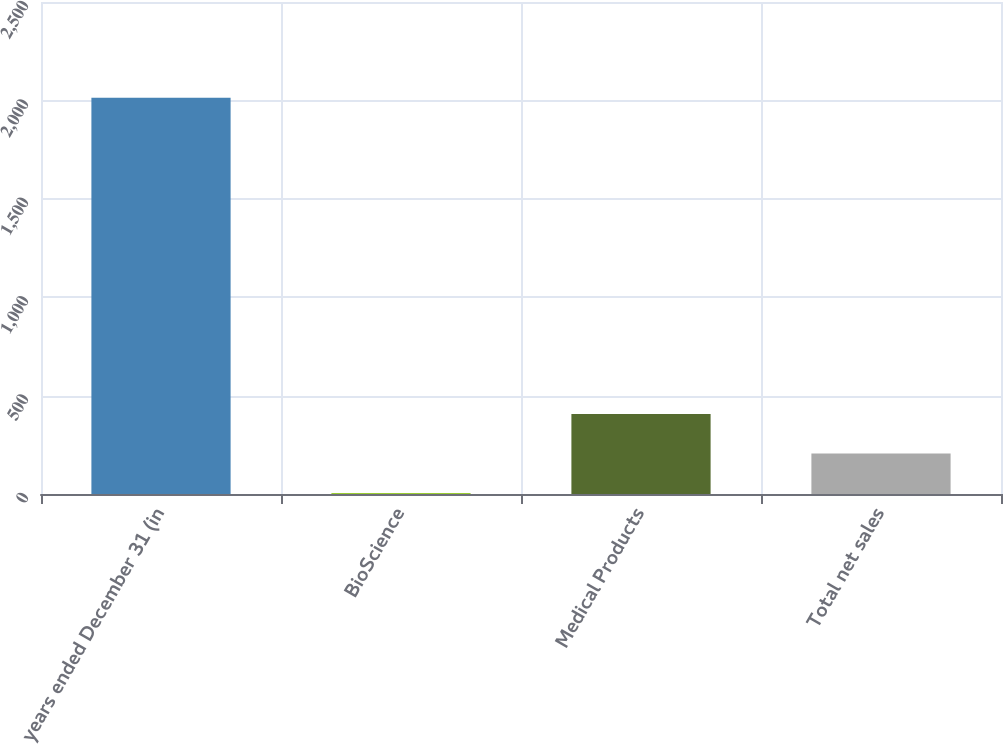Convert chart to OTSL. <chart><loc_0><loc_0><loc_500><loc_500><bar_chart><fcel>years ended December 31 (in<fcel>BioScience<fcel>Medical Products<fcel>Total net sales<nl><fcel>2013<fcel>5<fcel>406.6<fcel>205.8<nl></chart> 